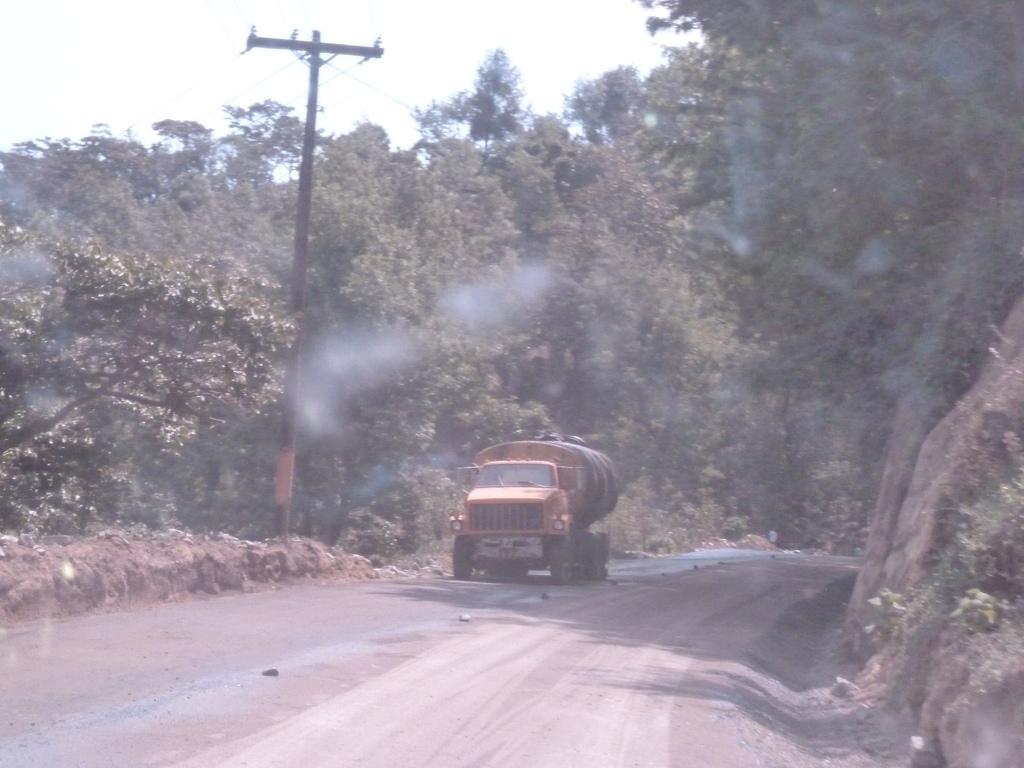How would you summarize this image in a sentence or two? In the foreground we can see plants, road and soil. In the middle there are trees, current pole, cables and a truck. At the top there is sky. 